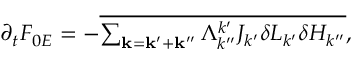<formula> <loc_0><loc_0><loc_500><loc_500>\begin{array} { r } { \partial _ { t } F _ { 0 E } = - \overline { { \sum _ { k = k ^ { \prime } + k ^ { \prime \prime } } \Lambda _ { k ^ { \prime \prime } } ^ { k ^ { \prime } } J _ { k ^ { \prime } } \delta L _ { k ^ { \prime } } \delta H _ { k ^ { \prime \prime } } } } , } \end{array}</formula> 